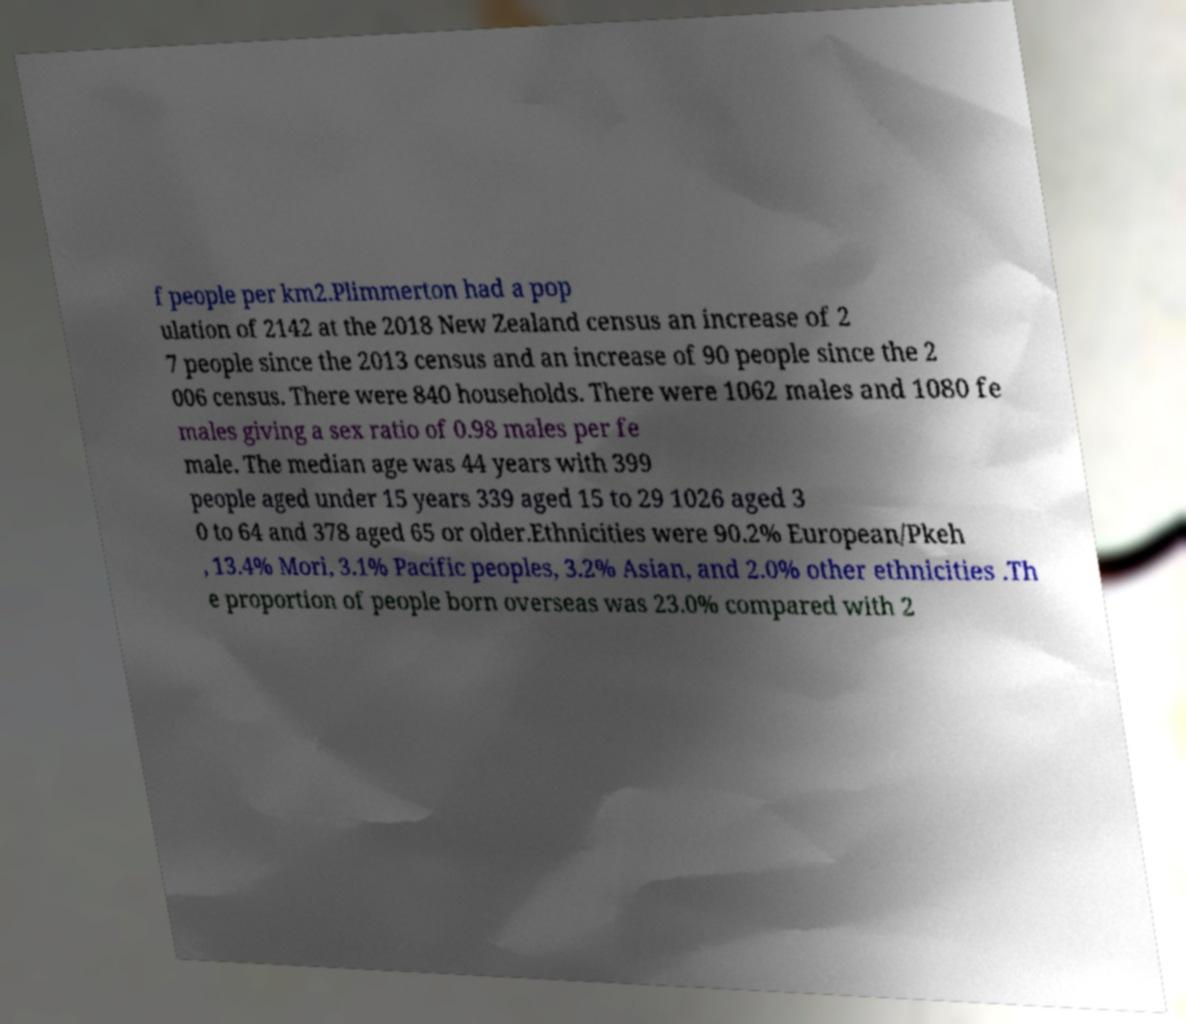Can you read and provide the text displayed in the image?This photo seems to have some interesting text. Can you extract and type it out for me? f people per km2.Plimmerton had a pop ulation of 2142 at the 2018 New Zealand census an increase of 2 7 people since the 2013 census and an increase of 90 people since the 2 006 census. There were 840 households. There were 1062 males and 1080 fe males giving a sex ratio of 0.98 males per fe male. The median age was 44 years with 399 people aged under 15 years 339 aged 15 to 29 1026 aged 3 0 to 64 and 378 aged 65 or older.Ethnicities were 90.2% European/Pkeh , 13.4% Mori, 3.1% Pacific peoples, 3.2% Asian, and 2.0% other ethnicities .Th e proportion of people born overseas was 23.0% compared with 2 